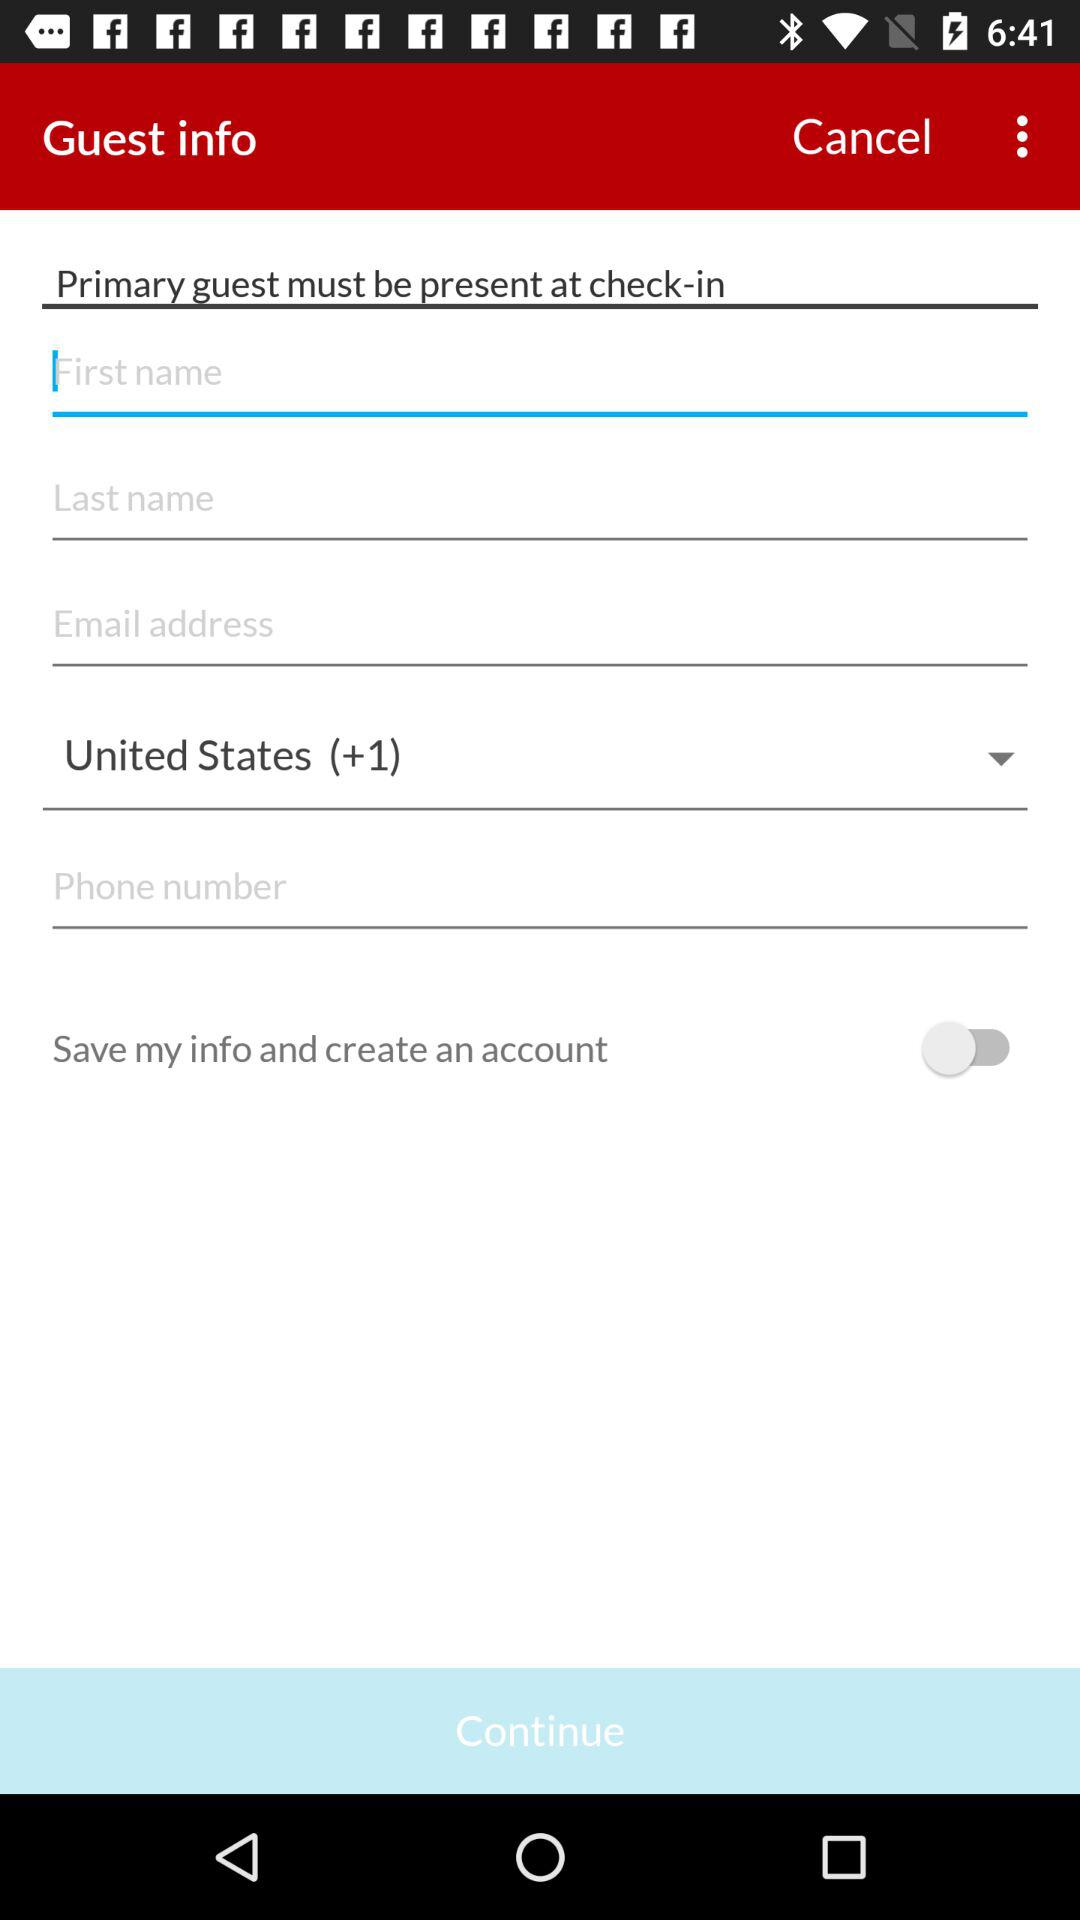How many text inputs are there that require the user to enter a phone number?
Answer the question using a single word or phrase. 1 